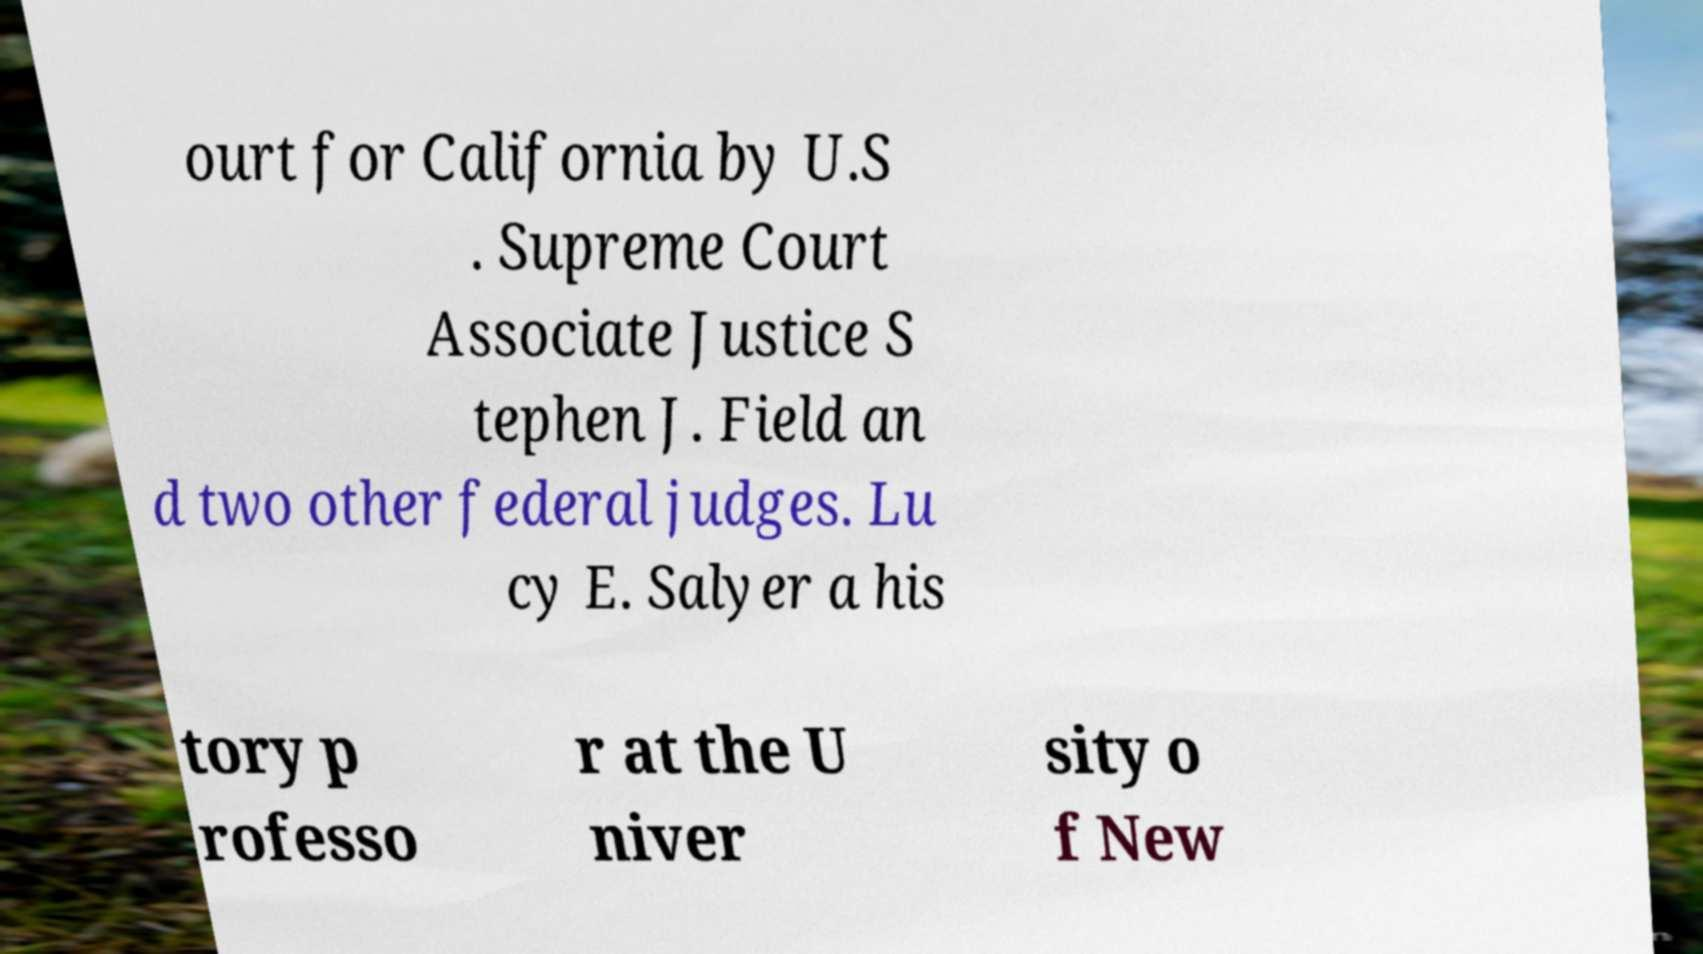Please read and relay the text visible in this image. What does it say? ourt for California by U.S . Supreme Court Associate Justice S tephen J. Field an d two other federal judges. Lu cy E. Salyer a his tory p rofesso r at the U niver sity o f New 